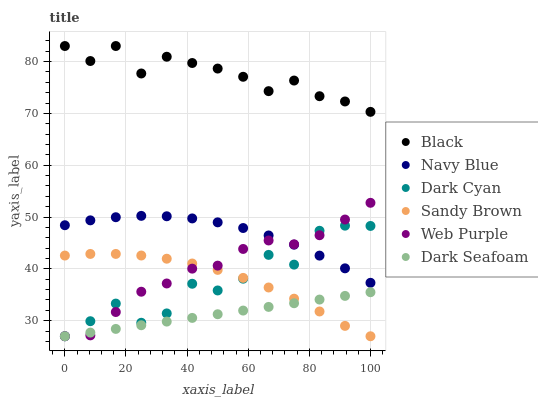Does Dark Seafoam have the minimum area under the curve?
Answer yes or no. Yes. Does Black have the maximum area under the curve?
Answer yes or no. Yes. Does Web Purple have the minimum area under the curve?
Answer yes or no. No. Does Web Purple have the maximum area under the curve?
Answer yes or no. No. Is Dark Seafoam the smoothest?
Answer yes or no. Yes. Is Dark Cyan the roughest?
Answer yes or no. Yes. Is Web Purple the smoothest?
Answer yes or no. No. Is Web Purple the roughest?
Answer yes or no. No. Does Dark Seafoam have the lowest value?
Answer yes or no. Yes. Does Black have the lowest value?
Answer yes or no. No. Does Black have the highest value?
Answer yes or no. Yes. Does Web Purple have the highest value?
Answer yes or no. No. Is Dark Seafoam less than Navy Blue?
Answer yes or no. Yes. Is Black greater than Navy Blue?
Answer yes or no. Yes. Does Dark Cyan intersect Sandy Brown?
Answer yes or no. Yes. Is Dark Cyan less than Sandy Brown?
Answer yes or no. No. Is Dark Cyan greater than Sandy Brown?
Answer yes or no. No. Does Dark Seafoam intersect Navy Blue?
Answer yes or no. No. 